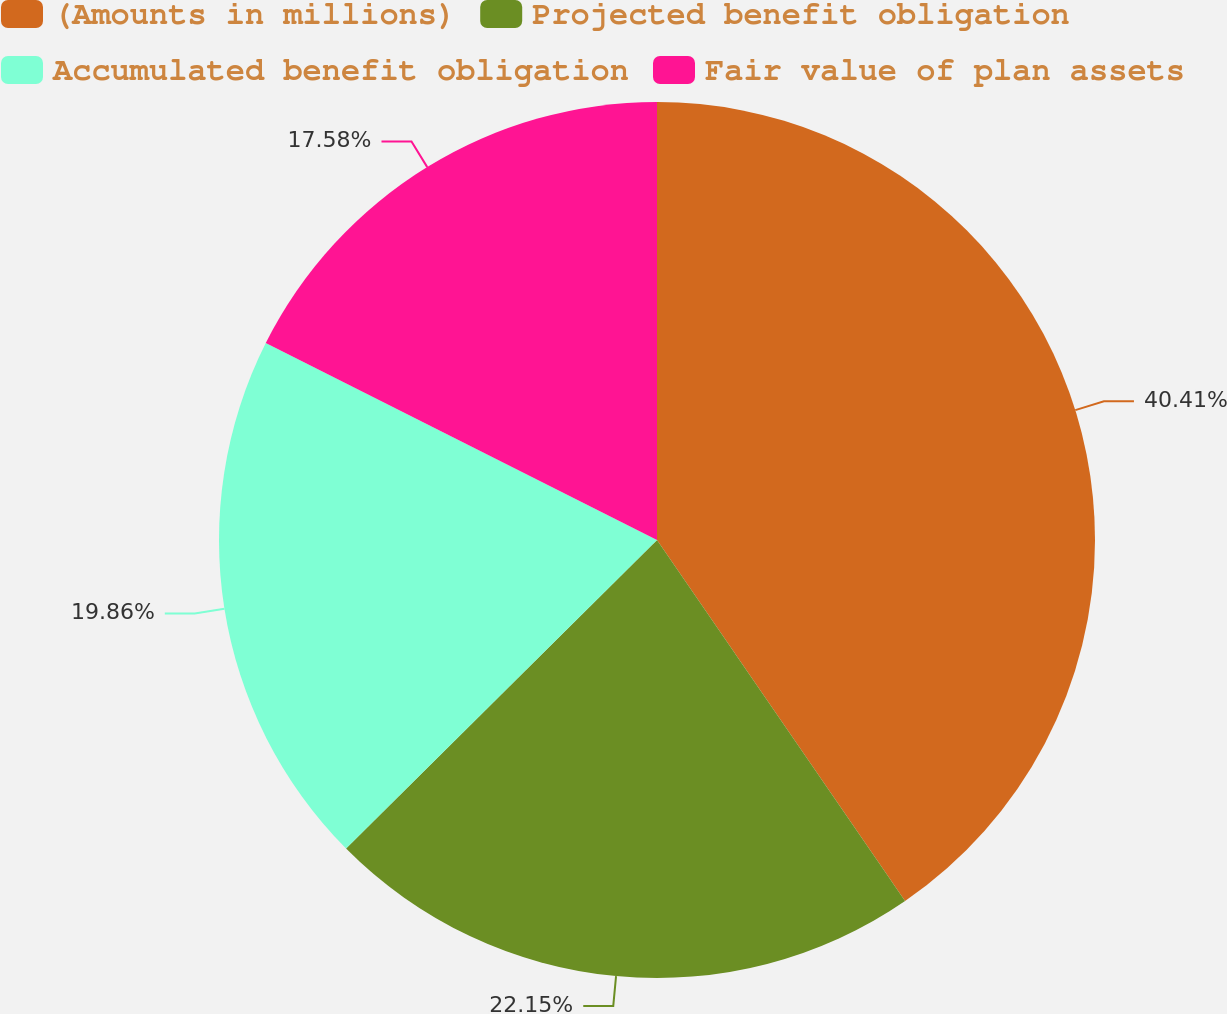Convert chart to OTSL. <chart><loc_0><loc_0><loc_500><loc_500><pie_chart><fcel>(Amounts in millions)<fcel>Projected benefit obligation<fcel>Accumulated benefit obligation<fcel>Fair value of plan assets<nl><fcel>40.42%<fcel>22.15%<fcel>19.86%<fcel>17.58%<nl></chart> 